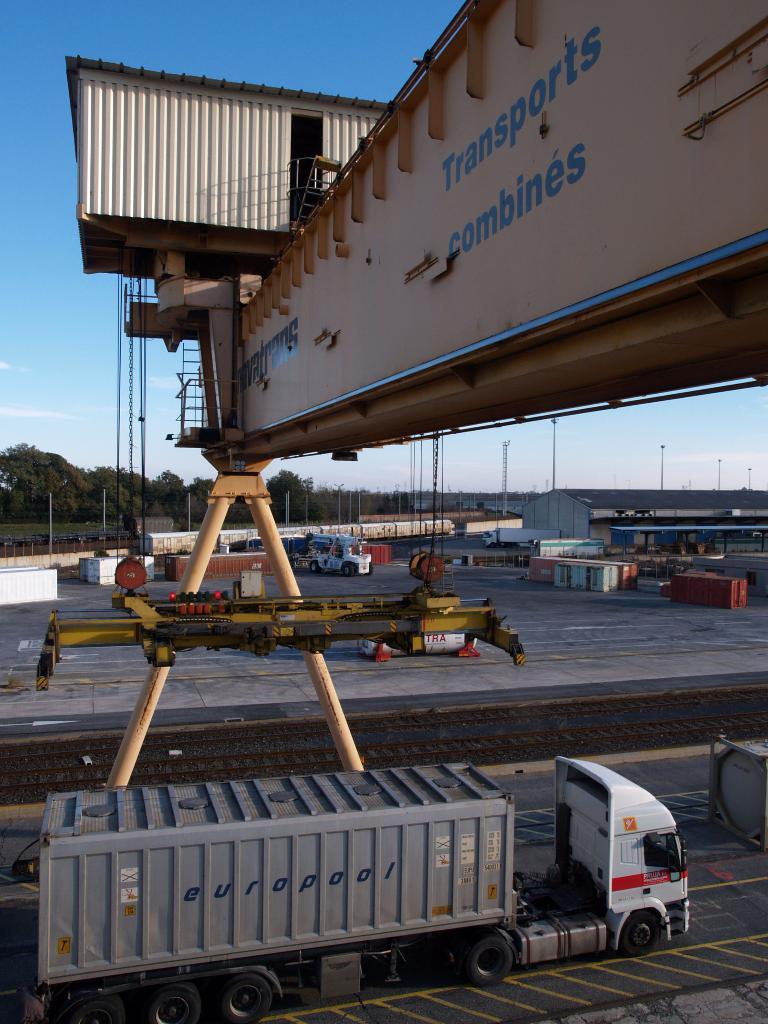Can you describe this image briefly? In this picture we can see a truck at the bottom, we can see a container on the truck, in the background we can see a vehicle, some containers and a shed, we can see a crane in the front, on the left side there are some trees and a train, we can also see some poles in the background there is the sky at the top of the picture. 